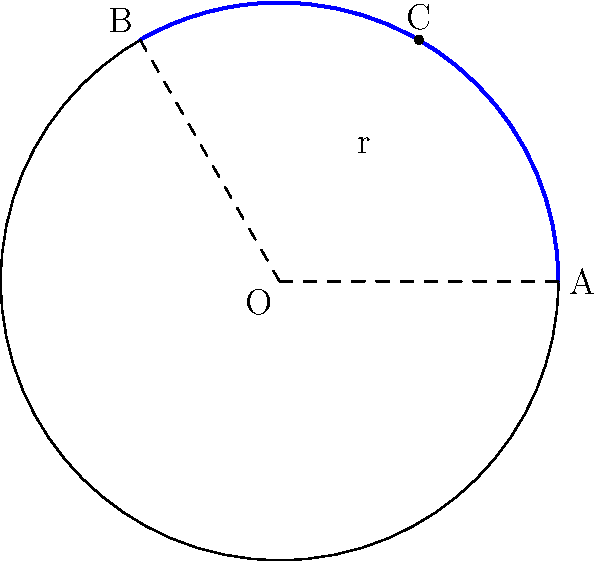In your latest religious masterpiece, you've incorporated a halo above a saint's head. The halo is represented by an arc of a circle with radius 6 inches. If the arc spans an angle of 120°, what is the length of the arc in inches? Round your answer to two decimal places. To solve this problem, we'll use the formula for arc length:

$$ s = r\theta $$

Where:
$s$ = arc length
$r$ = radius of the circle
$\theta$ = central angle in radians

Step 1: Convert the angle from degrees to radians
$$ \theta = 120° \times \frac{\pi}{180°} = \frac{2\pi}{3} \text{ radians} $$

Step 2: Apply the arc length formula
$$ s = r\theta = 6 \times \frac{2\pi}{3} = 4\pi \text{ inches} $$

Step 3: Calculate the numerical value and round to two decimal places
$$ s = 4\pi \approx 12.57 \text{ inches} $$

Thus, the length of the arc representing the halo is approximately 12.57 inches.
Answer: 12.57 inches 